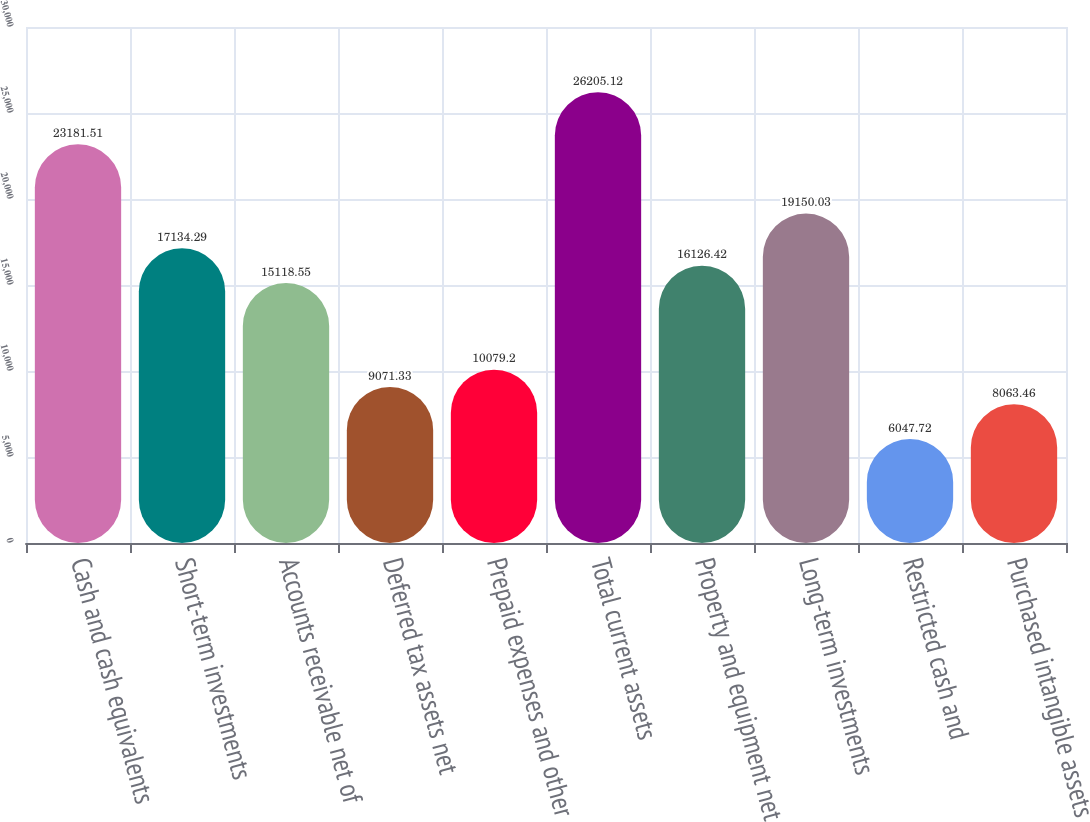Convert chart to OTSL. <chart><loc_0><loc_0><loc_500><loc_500><bar_chart><fcel>Cash and cash equivalents<fcel>Short-term investments<fcel>Accounts receivable net of<fcel>Deferred tax assets net<fcel>Prepaid expenses and other<fcel>Total current assets<fcel>Property and equipment net<fcel>Long-term investments<fcel>Restricted cash and<fcel>Purchased intangible assets<nl><fcel>23181.5<fcel>17134.3<fcel>15118.5<fcel>9071.33<fcel>10079.2<fcel>26205.1<fcel>16126.4<fcel>19150<fcel>6047.72<fcel>8063.46<nl></chart> 